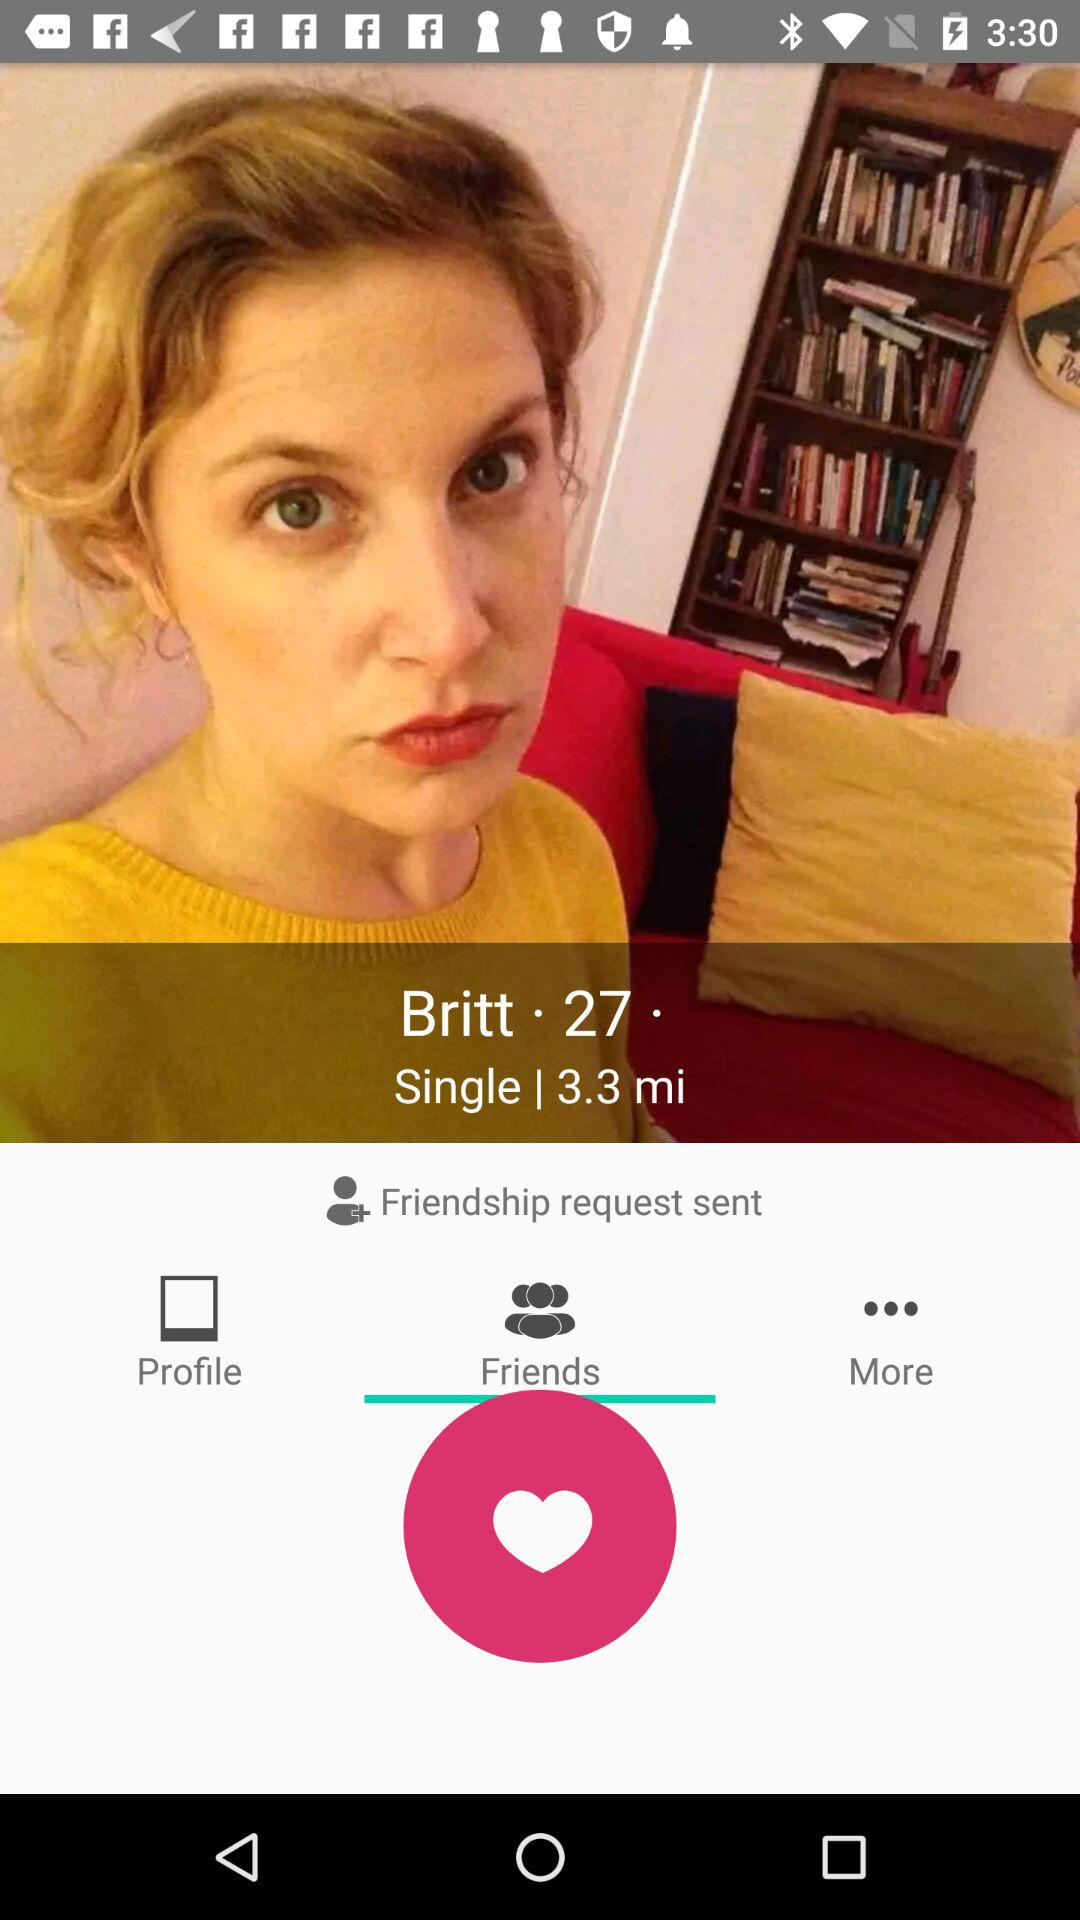Which city is Britt in?
When the provided information is insufficient, respond with <no answer>. <no answer> 